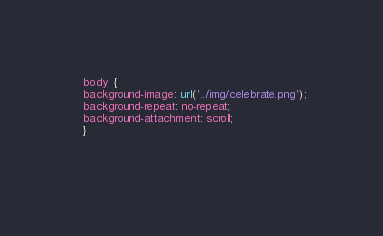<code> <loc_0><loc_0><loc_500><loc_500><_CSS_>  body {
  background-image: url('../img/celebrate.png');
  background-repeat: no-repeat;
  background-attachment: scroll;  
  }
 
 
</code> 